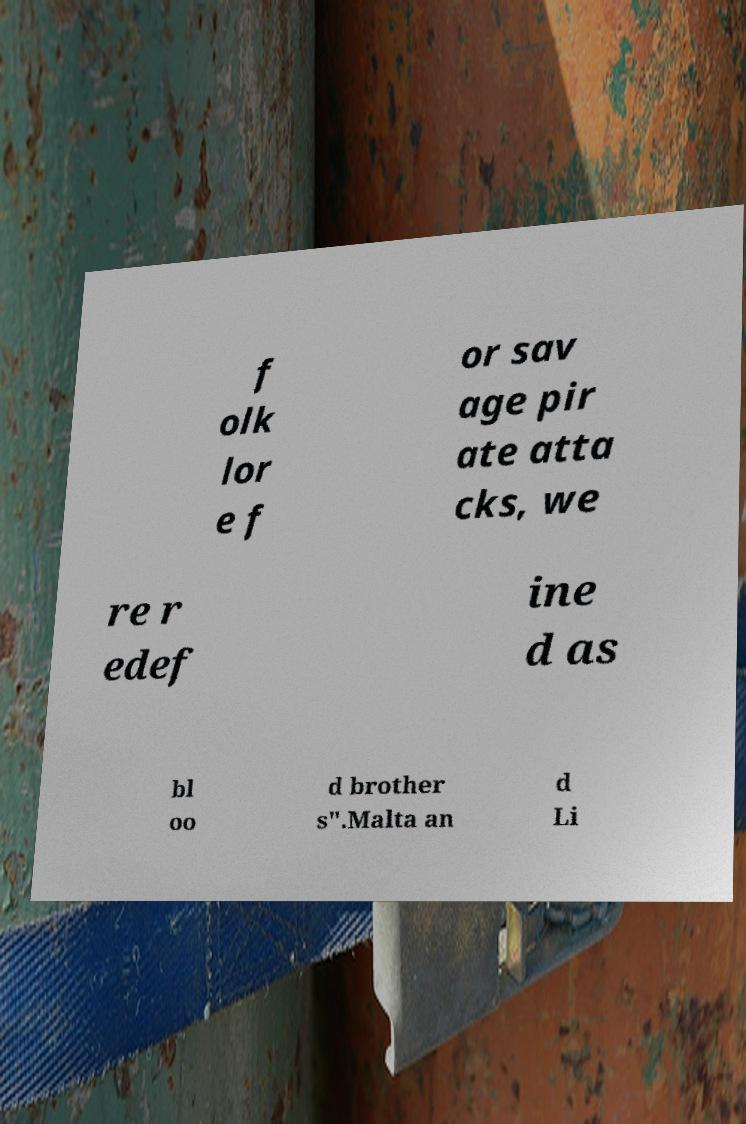Can you read and provide the text displayed in the image?This photo seems to have some interesting text. Can you extract and type it out for me? f olk lor e f or sav age pir ate atta cks, we re r edef ine d as bl oo d brother s".Malta an d Li 